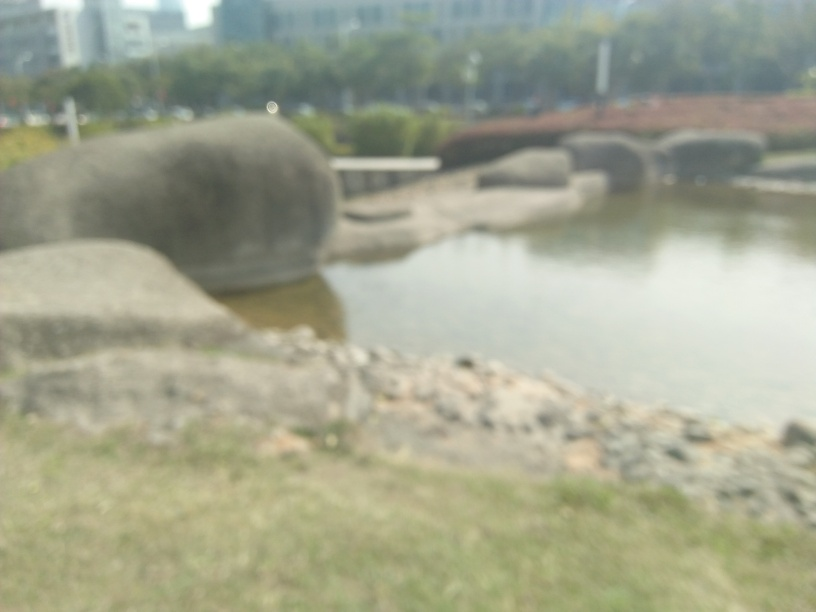How might the weather be affecting this image? From what can be observed, the weather seems bright, potentially indicating a sunny day. However, due to the blurred nature of the image, it is not possible to accurately determine weather conditions such as the presence of clouds, fog, or haze that could have impacted the image clarity. 